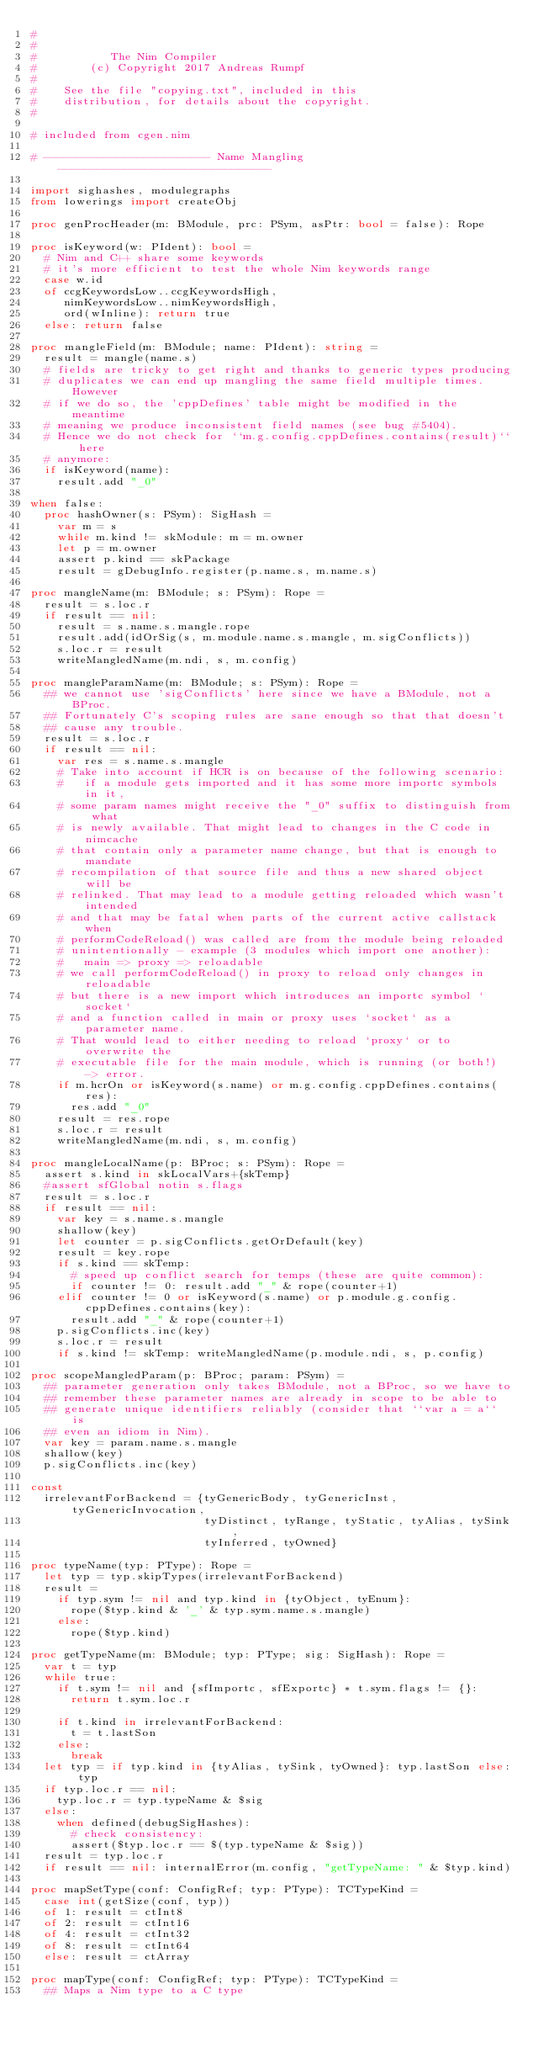<code> <loc_0><loc_0><loc_500><loc_500><_Nim_>#
#
#           The Nim Compiler
#        (c) Copyright 2017 Andreas Rumpf
#
#    See the file "copying.txt", included in this
#    distribution, for details about the copyright.
#

# included from cgen.nim

# ------------------------- Name Mangling --------------------------------

import sighashes, modulegraphs
from lowerings import createObj

proc genProcHeader(m: BModule, prc: PSym, asPtr: bool = false): Rope

proc isKeyword(w: PIdent): bool =
  # Nim and C++ share some keywords
  # it's more efficient to test the whole Nim keywords range
  case w.id
  of ccgKeywordsLow..ccgKeywordsHigh,
     nimKeywordsLow..nimKeywordsHigh,
     ord(wInline): return true
  else: return false

proc mangleField(m: BModule; name: PIdent): string =
  result = mangle(name.s)
  # fields are tricky to get right and thanks to generic types producing
  # duplicates we can end up mangling the same field multiple times. However
  # if we do so, the 'cppDefines' table might be modified in the meantime
  # meaning we produce inconsistent field names (see bug #5404).
  # Hence we do not check for ``m.g.config.cppDefines.contains(result)`` here
  # anymore:
  if isKeyword(name):
    result.add "_0"

when false:
  proc hashOwner(s: PSym): SigHash =
    var m = s
    while m.kind != skModule: m = m.owner
    let p = m.owner
    assert p.kind == skPackage
    result = gDebugInfo.register(p.name.s, m.name.s)

proc mangleName(m: BModule; s: PSym): Rope =
  result = s.loc.r
  if result == nil:
    result = s.name.s.mangle.rope
    result.add(idOrSig(s, m.module.name.s.mangle, m.sigConflicts))
    s.loc.r = result
    writeMangledName(m.ndi, s, m.config)

proc mangleParamName(m: BModule; s: PSym): Rope =
  ## we cannot use 'sigConflicts' here since we have a BModule, not a BProc.
  ## Fortunately C's scoping rules are sane enough so that that doesn't
  ## cause any trouble.
  result = s.loc.r
  if result == nil:
    var res = s.name.s.mangle
    # Take into account if HCR is on because of the following scenario:
    #   if a module gets imported and it has some more importc symbols in it,
    # some param names might receive the "_0" suffix to distinguish from what
    # is newly available. That might lead to changes in the C code in nimcache
    # that contain only a parameter name change, but that is enough to mandate
    # recompilation of that source file and thus a new shared object will be
    # relinked. That may lead to a module getting reloaded which wasn't intended
    # and that may be fatal when parts of the current active callstack when
    # performCodeReload() was called are from the module being reloaded
    # unintentionally - example (3 modules which import one another):
    #   main => proxy => reloadable
    # we call performCodeReload() in proxy to reload only changes in reloadable
    # but there is a new import which introduces an importc symbol `socket`
    # and a function called in main or proxy uses `socket` as a parameter name.
    # That would lead to either needing to reload `proxy` or to overwrite the
    # executable file for the main module, which is running (or both!) -> error.
    if m.hcrOn or isKeyword(s.name) or m.g.config.cppDefines.contains(res):
      res.add "_0"
    result = res.rope
    s.loc.r = result
    writeMangledName(m.ndi, s, m.config)

proc mangleLocalName(p: BProc; s: PSym): Rope =
  assert s.kind in skLocalVars+{skTemp}
  #assert sfGlobal notin s.flags
  result = s.loc.r
  if result == nil:
    var key = s.name.s.mangle
    shallow(key)
    let counter = p.sigConflicts.getOrDefault(key)
    result = key.rope
    if s.kind == skTemp:
      # speed up conflict search for temps (these are quite common):
      if counter != 0: result.add "_" & rope(counter+1)
    elif counter != 0 or isKeyword(s.name) or p.module.g.config.cppDefines.contains(key):
      result.add "_" & rope(counter+1)
    p.sigConflicts.inc(key)
    s.loc.r = result
    if s.kind != skTemp: writeMangledName(p.module.ndi, s, p.config)

proc scopeMangledParam(p: BProc; param: PSym) =
  ## parameter generation only takes BModule, not a BProc, so we have to
  ## remember these parameter names are already in scope to be able to
  ## generate unique identifiers reliably (consider that ``var a = a`` is
  ## even an idiom in Nim).
  var key = param.name.s.mangle
  shallow(key)
  p.sigConflicts.inc(key)

const
  irrelevantForBackend = {tyGenericBody, tyGenericInst, tyGenericInvocation,
                          tyDistinct, tyRange, tyStatic, tyAlias, tySink,
                          tyInferred, tyOwned}

proc typeName(typ: PType): Rope =
  let typ = typ.skipTypes(irrelevantForBackend)
  result =
    if typ.sym != nil and typ.kind in {tyObject, tyEnum}:
      rope($typ.kind & '_' & typ.sym.name.s.mangle)
    else:
      rope($typ.kind)

proc getTypeName(m: BModule; typ: PType; sig: SigHash): Rope =
  var t = typ
  while true:
    if t.sym != nil and {sfImportc, sfExportc} * t.sym.flags != {}:
      return t.sym.loc.r

    if t.kind in irrelevantForBackend:
      t = t.lastSon
    else:
      break
  let typ = if typ.kind in {tyAlias, tySink, tyOwned}: typ.lastSon else: typ
  if typ.loc.r == nil:
    typ.loc.r = typ.typeName & $sig
  else:
    when defined(debugSigHashes):
      # check consistency:
      assert($typ.loc.r == $(typ.typeName & $sig))
  result = typ.loc.r
  if result == nil: internalError(m.config, "getTypeName: " & $typ.kind)

proc mapSetType(conf: ConfigRef; typ: PType): TCTypeKind =
  case int(getSize(conf, typ))
  of 1: result = ctInt8
  of 2: result = ctInt16
  of 4: result = ctInt32
  of 8: result = ctInt64
  else: result = ctArray

proc mapType(conf: ConfigRef; typ: PType): TCTypeKind =
  ## Maps a Nim type to a C type</code> 